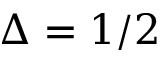Convert formula to latex. <formula><loc_0><loc_0><loc_500><loc_500>\Delta = 1 / 2</formula> 